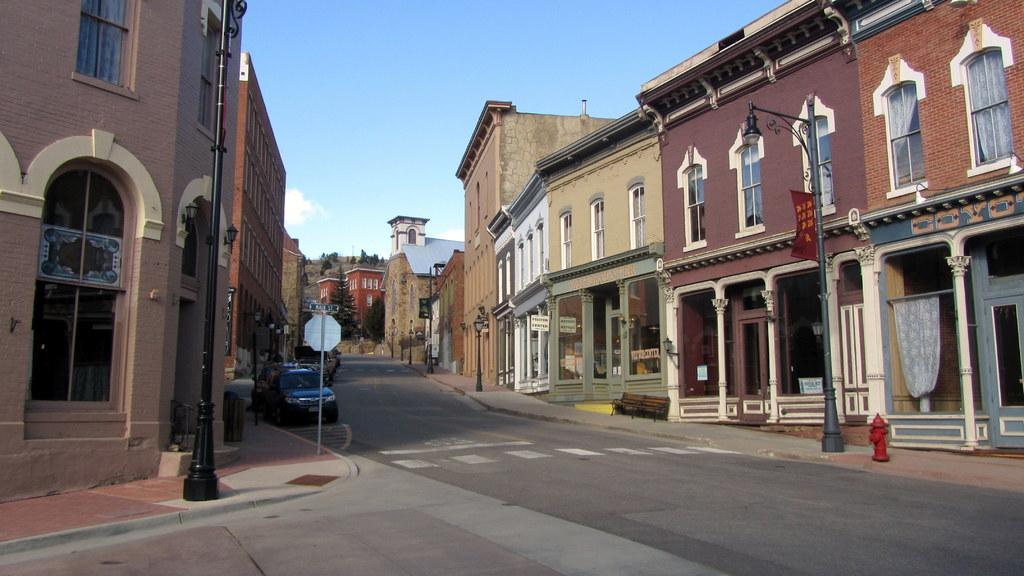How would you summarize this image in a sentence or two? In this image in the middle there is a road. Here there are cars. On both sides of the road there are buildings, street lights, sign board. This is a fire hydrant. In the background there are trees, building. The sky is cloudy. 